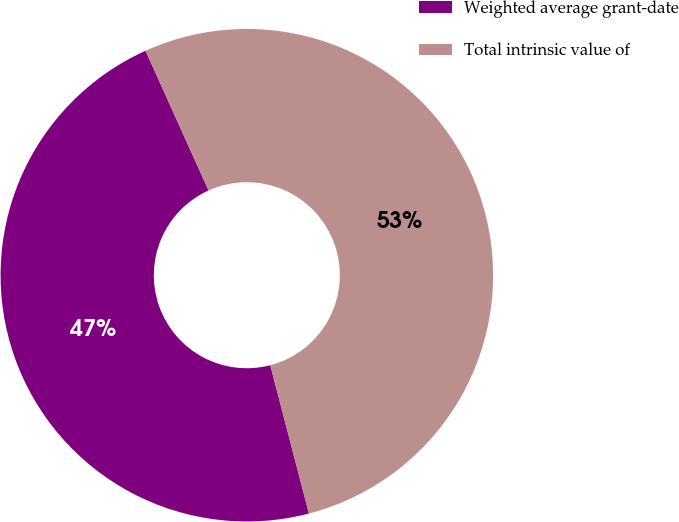Convert chart to OTSL. <chart><loc_0><loc_0><loc_500><loc_500><pie_chart><fcel>Weighted average grant-date<fcel>Total intrinsic value of<nl><fcel>47.31%<fcel>52.69%<nl></chart> 